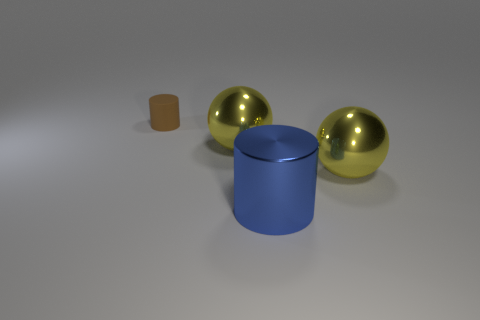Is the tiny matte cylinder the same color as the shiny cylinder?
Make the answer very short. No. What number of things are metallic things that are to the right of the blue cylinder or blue objects?
Provide a short and direct response. 2. There is a metal ball that is in front of the big ball that is to the left of the cylinder that is on the right side of the small brown matte object; what is its color?
Give a very brief answer. Yellow. How many spheres are made of the same material as the big cylinder?
Provide a succinct answer. 2. Is the size of the shiny object that is to the left of the metallic cylinder the same as the small cylinder?
Offer a terse response. No. There is a large blue cylinder; what number of large yellow things are in front of it?
Provide a short and direct response. 0. Are any large yellow metal spheres visible?
Your answer should be very brief. Yes. What is the size of the yellow shiny thing behind the yellow metallic ball that is right of the large yellow ball left of the blue cylinder?
Provide a short and direct response. Large. What number of other things are the same size as the matte object?
Offer a terse response. 0. There is a cylinder to the right of the tiny matte thing; what is its size?
Provide a short and direct response. Large. 